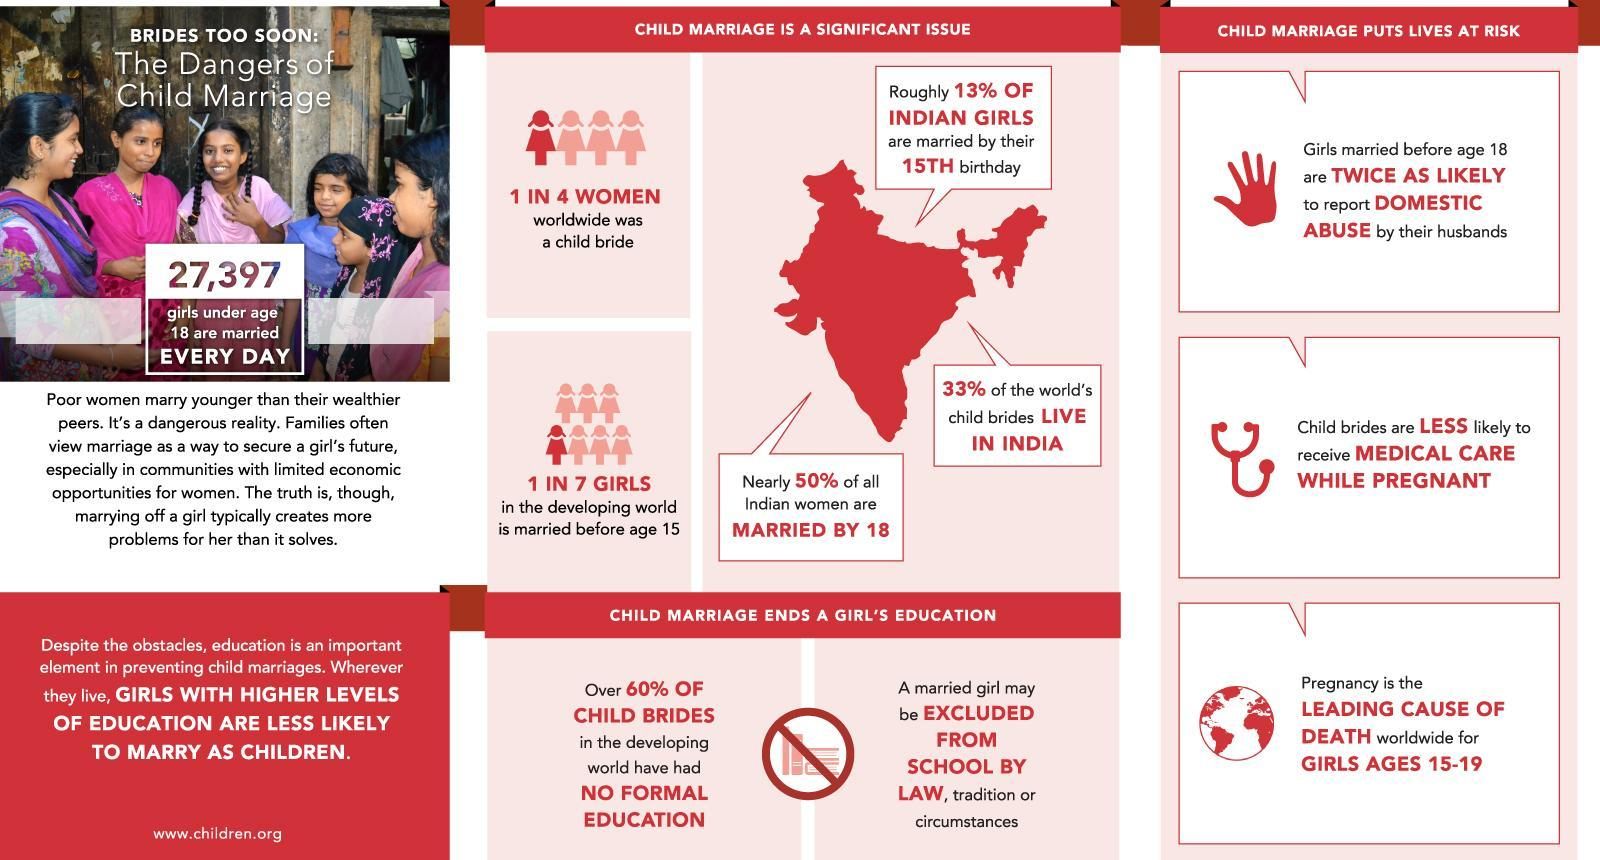What percent of world's child brides live in other part of the world?
Answer the question with a short phrase. 67% 